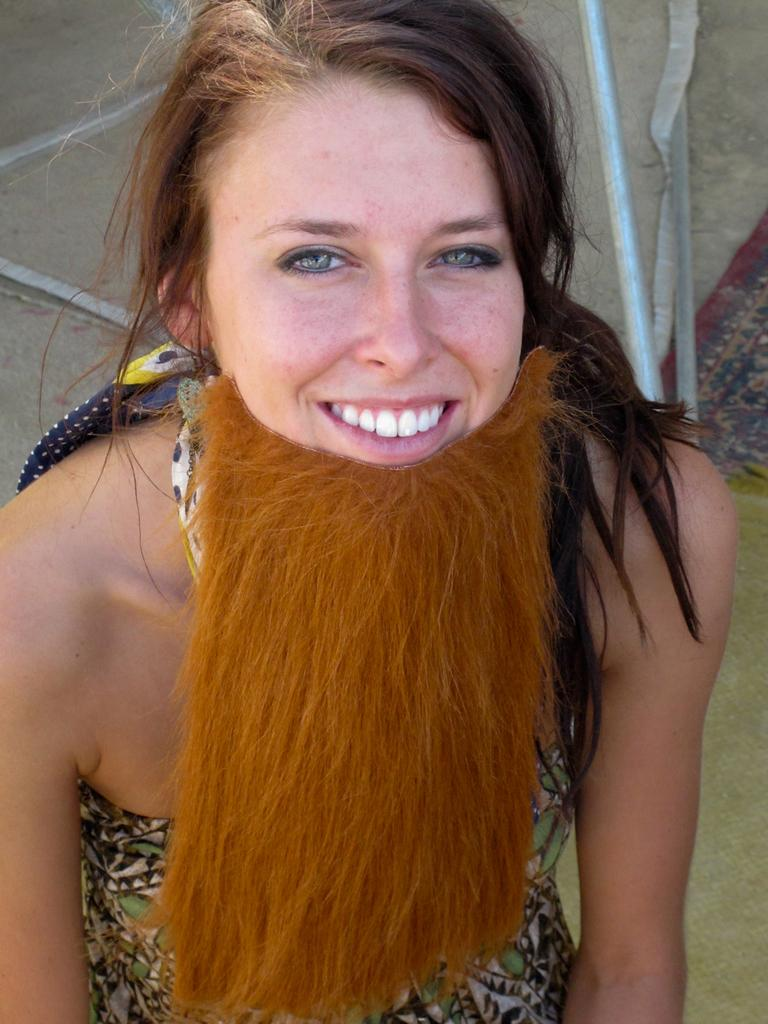Who is the main subject in the image? There is a woman in the image. What is the woman doing in the image? The woman is sitting. What is unique about the woman's appearance in the image? The woman is wearing a fake beard. What is the woman's facial expression in the image? The woman is smiling. What type of books can be seen tied together with a string in the image? There are no books or string present in the image. What is the woman using to iron her clothes in the image? There is no iron or ironing activity depicted in the image. 